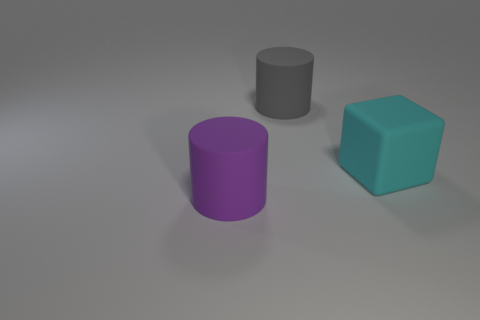What material is the large cylinder in front of the cyan matte thing?
Make the answer very short. Rubber. There is a cylinder that is on the left side of the gray rubber object; is it the same size as the cylinder that is behind the purple thing?
Your response must be concise. Yes. How big is the thing that is left of the big cyan block and in front of the gray matte thing?
Your answer should be compact. Large. What color is the other large matte thing that is the same shape as the large purple matte object?
Your response must be concise. Gray. Are there more large blocks behind the large gray matte thing than cylinders behind the purple cylinder?
Your answer should be very brief. No. What number of other objects are the same shape as the gray rubber object?
Your answer should be compact. 1. There is a big cyan block that is right of the gray object; are there any big cubes in front of it?
Offer a very short reply. No. How many cyan blocks are there?
Make the answer very short. 1. Is the color of the cube the same as the object that is behind the large cyan matte block?
Offer a terse response. No. Is the number of big things greater than the number of large purple rubber objects?
Keep it short and to the point. Yes. 